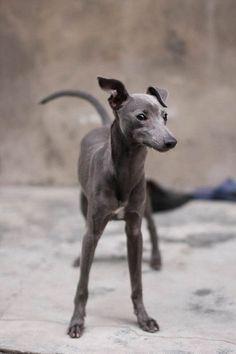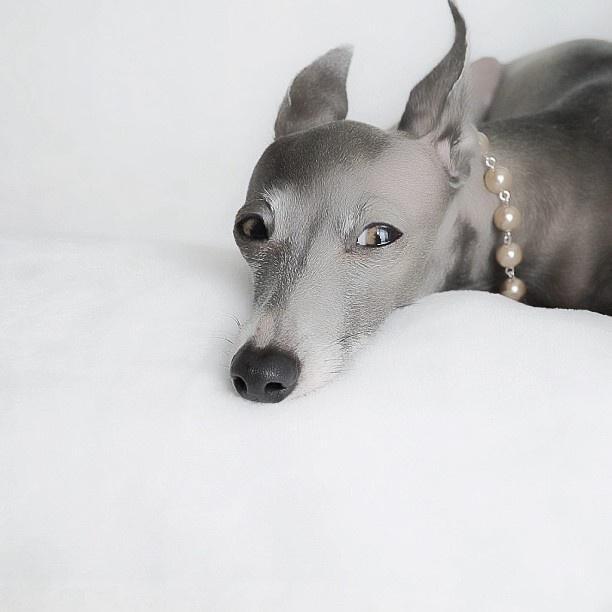The first image is the image on the left, the second image is the image on the right. Considering the images on both sides, is "A dog with a necklace is lying down in one of the images." valid? Answer yes or no. Yes. The first image is the image on the left, the second image is the image on the right. Given the left and right images, does the statement "An image shows a hound wearing a pearl-look necklace." hold true? Answer yes or no. Yes. 